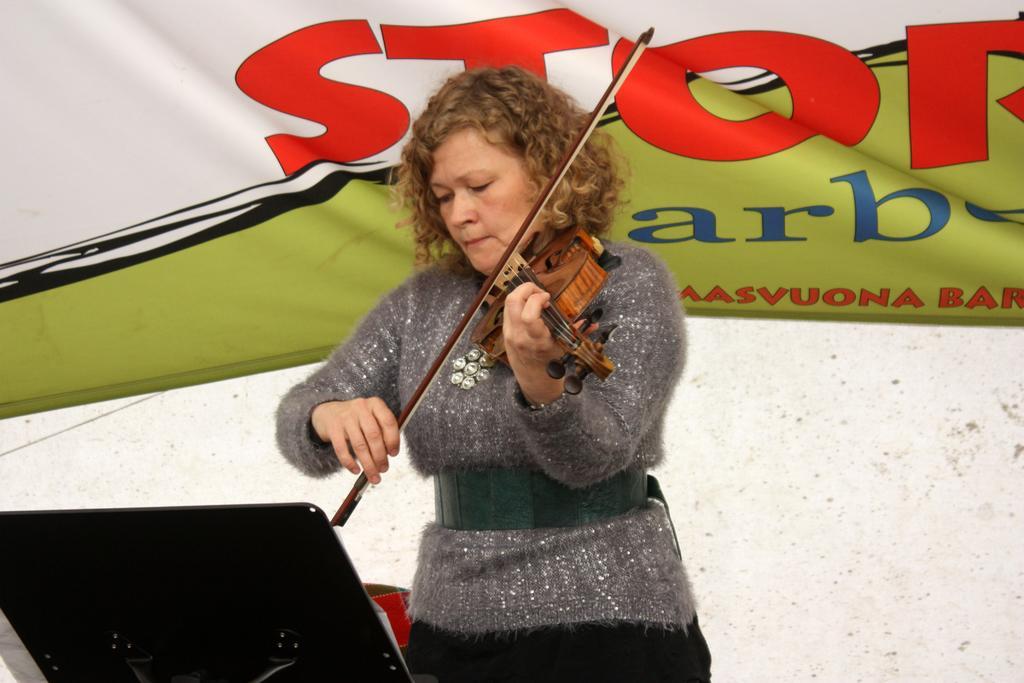Describe this image in one or two sentences. In this image I see a woman who is standing and she is holding a musical instrument in her hands and there is a stand in front of her. In the background I see the banner. 